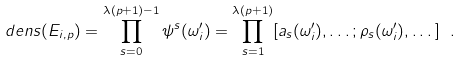Convert formula to latex. <formula><loc_0><loc_0><loc_500><loc_500>d e n s ( E _ { i , p } ) = \prod _ { s = 0 } ^ { \lambda ( p + 1 ) - 1 } \psi ^ { s } ( \omega _ { i } ^ { \prime } ) = \prod _ { s = 1 } ^ { \lambda ( p + 1 ) } [ a _ { s } ( \omega _ { i } ^ { \prime } ) , \dots ; \rho _ { s } ( \omega _ { i } ^ { \prime } ) , \dots ] \ .</formula> 